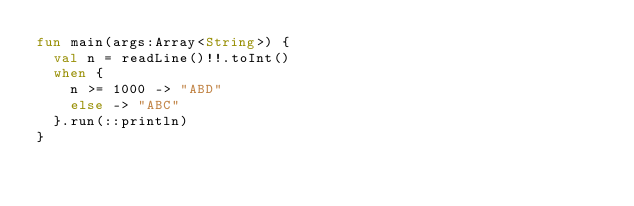<code> <loc_0><loc_0><loc_500><loc_500><_Kotlin_>fun main(args:Array<String>) {
  val n = readLine()!!.toInt()
  when {
    n >= 1000 -> "ABD"
    else -> "ABC"
  }.run(::println)
}</code> 